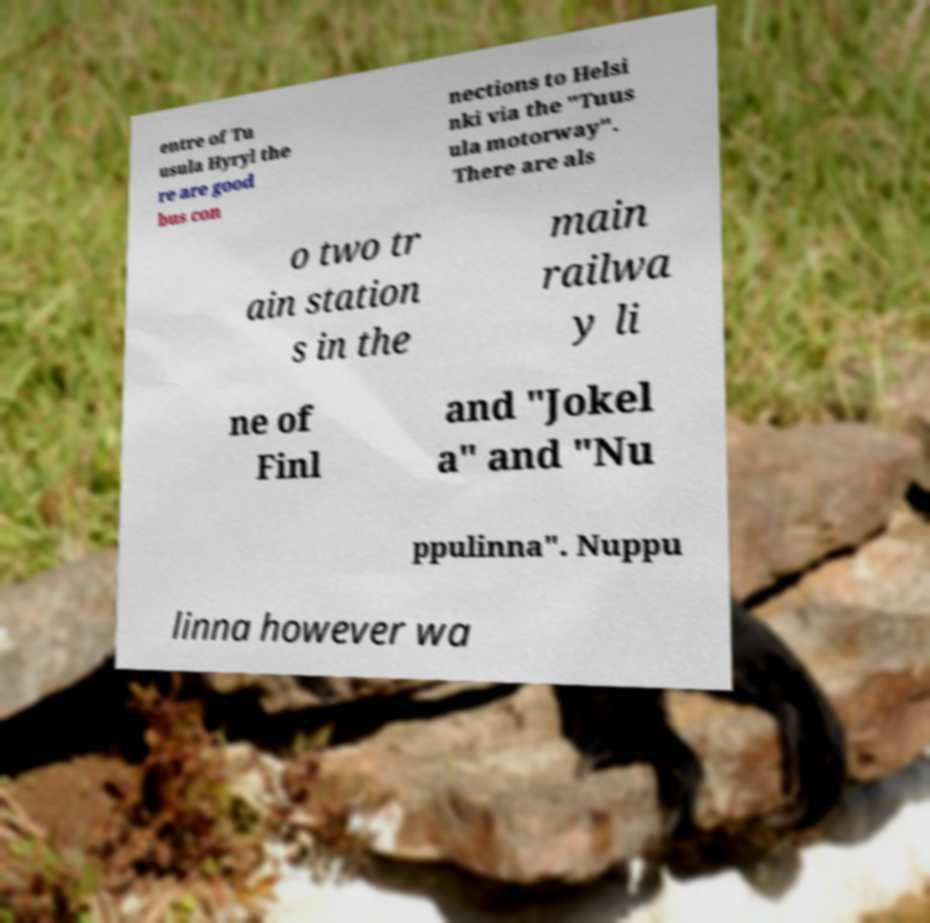Can you read and provide the text displayed in the image?This photo seems to have some interesting text. Can you extract and type it out for me? entre of Tu usula Hyryl the re are good bus con nections to Helsi nki via the "Tuus ula motorway". There are als o two tr ain station s in the main railwa y li ne of Finl and "Jokel a" and "Nu ppulinna". Nuppu linna however wa 